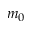Convert formula to latex. <formula><loc_0><loc_0><loc_500><loc_500>m _ { 0 }</formula> 